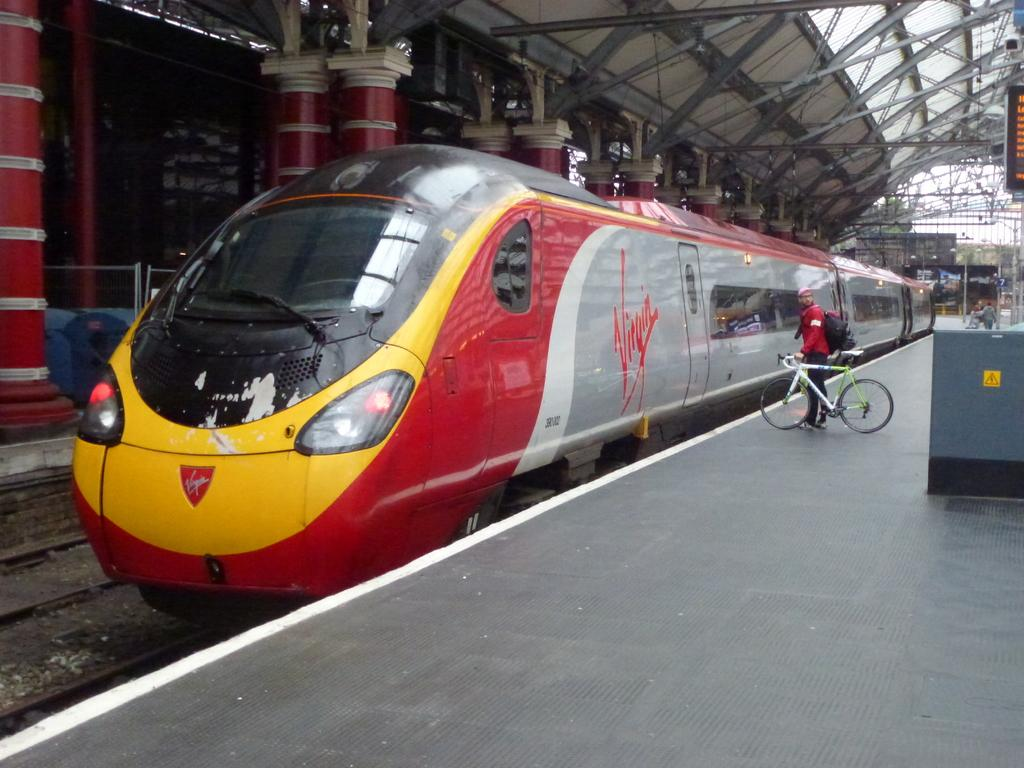<image>
Write a terse but informative summary of the picture. Train that has a Virgin logo on the side of it, and a man is on a bicycle waiting for the train. 